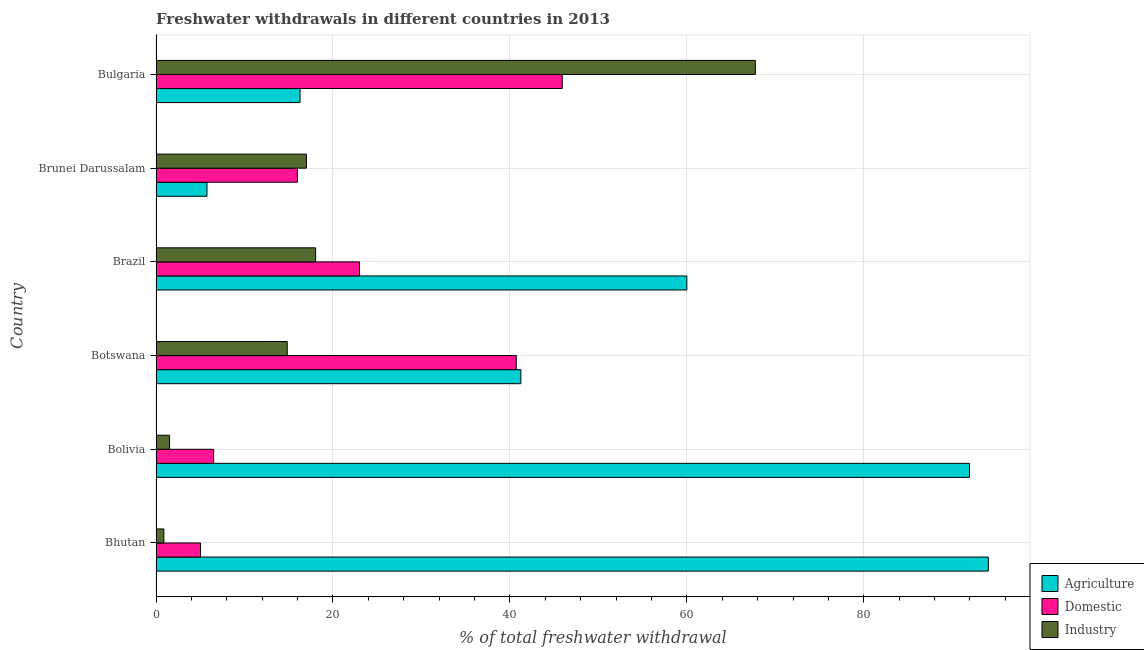How many different coloured bars are there?
Your response must be concise. 3. Are the number of bars per tick equal to the number of legend labels?
Ensure brevity in your answer.  Yes. How many bars are there on the 3rd tick from the top?
Ensure brevity in your answer.  3. What is the label of the 4th group of bars from the top?
Keep it short and to the point. Botswana. What is the percentage of freshwater withdrawal for domestic purposes in Brunei Darussalam?
Your answer should be very brief. 15.98. Across all countries, what is the maximum percentage of freshwater withdrawal for industry?
Offer a terse response. 67.74. Across all countries, what is the minimum percentage of freshwater withdrawal for domestic purposes?
Offer a very short reply. 5.03. In which country was the percentage of freshwater withdrawal for industry maximum?
Provide a succinct answer. Bulgaria. In which country was the percentage of freshwater withdrawal for domestic purposes minimum?
Ensure brevity in your answer.  Bhutan. What is the total percentage of freshwater withdrawal for agriculture in the graph?
Provide a succinct answer. 309.31. What is the difference between the percentage of freshwater withdrawal for agriculture in Brunei Darussalam and that in Bulgaria?
Give a very brief answer. -10.52. What is the difference between the percentage of freshwater withdrawal for agriculture in Bulgaria and the percentage of freshwater withdrawal for domestic purposes in Brunei Darussalam?
Provide a succinct answer. 0.3. What is the average percentage of freshwater withdrawal for agriculture per country?
Your response must be concise. 51.55. What is the difference between the percentage of freshwater withdrawal for industry and percentage of freshwater withdrawal for domestic purposes in Bhutan?
Offer a terse response. -4.14. What is the ratio of the percentage of freshwater withdrawal for industry in Bolivia to that in Brunei Darussalam?
Give a very brief answer. 0.09. Is the difference between the percentage of freshwater withdrawal for agriculture in Bolivia and Botswana greater than the difference between the percentage of freshwater withdrawal for industry in Bolivia and Botswana?
Provide a short and direct response. Yes. What is the difference between the highest and the lowest percentage of freshwater withdrawal for agriculture?
Provide a succinct answer. 88.32. In how many countries, is the percentage of freshwater withdrawal for industry greater than the average percentage of freshwater withdrawal for industry taken over all countries?
Provide a short and direct response. 1. What does the 3rd bar from the top in Bolivia represents?
Make the answer very short. Agriculture. What does the 1st bar from the bottom in Bolivia represents?
Give a very brief answer. Agriculture. Is it the case that in every country, the sum of the percentage of freshwater withdrawal for agriculture and percentage of freshwater withdrawal for domestic purposes is greater than the percentage of freshwater withdrawal for industry?
Make the answer very short. No. How many bars are there?
Ensure brevity in your answer.  18. Are the values on the major ticks of X-axis written in scientific E-notation?
Offer a terse response. No. Where does the legend appear in the graph?
Your response must be concise. Bottom right. How many legend labels are there?
Your answer should be very brief. 3. What is the title of the graph?
Offer a very short reply. Freshwater withdrawals in different countries in 2013. Does "Profit Tax" appear as one of the legend labels in the graph?
Ensure brevity in your answer.  No. What is the label or title of the X-axis?
Ensure brevity in your answer.  % of total freshwater withdrawal. What is the % of total freshwater withdrawal in Agriculture in Bhutan?
Your response must be concise. 94.08. What is the % of total freshwater withdrawal of Domestic in Bhutan?
Your answer should be compact. 5.03. What is the % of total freshwater withdrawal in Industry in Bhutan?
Provide a short and direct response. 0.89. What is the % of total freshwater withdrawal of Agriculture in Bolivia?
Make the answer very short. 91.95. What is the % of total freshwater withdrawal in Domestic in Bolivia?
Your response must be concise. 6.51. What is the % of total freshwater withdrawal of Industry in Bolivia?
Offer a terse response. 1.53. What is the % of total freshwater withdrawal in Agriculture in Botswana?
Offer a terse response. 41.24. What is the % of total freshwater withdrawal of Domestic in Botswana?
Make the answer very short. 40.72. What is the % of total freshwater withdrawal in Industry in Botswana?
Provide a short and direct response. 14.83. What is the % of total freshwater withdrawal of Agriculture in Brazil?
Offer a terse response. 60. What is the % of total freshwater withdrawal of Industry in Brazil?
Ensure brevity in your answer.  18.04. What is the % of total freshwater withdrawal of Agriculture in Brunei Darussalam?
Ensure brevity in your answer.  5.76. What is the % of total freshwater withdrawal in Domestic in Brunei Darussalam?
Your response must be concise. 15.98. What is the % of total freshwater withdrawal in Agriculture in Bulgaria?
Give a very brief answer. 16.28. What is the % of total freshwater withdrawal of Domestic in Bulgaria?
Provide a short and direct response. 45.92. What is the % of total freshwater withdrawal in Industry in Bulgaria?
Offer a very short reply. 67.74. Across all countries, what is the maximum % of total freshwater withdrawal in Agriculture?
Offer a very short reply. 94.08. Across all countries, what is the maximum % of total freshwater withdrawal of Domestic?
Provide a short and direct response. 45.92. Across all countries, what is the maximum % of total freshwater withdrawal in Industry?
Your response must be concise. 67.74. Across all countries, what is the minimum % of total freshwater withdrawal in Agriculture?
Your answer should be very brief. 5.76. Across all countries, what is the minimum % of total freshwater withdrawal of Domestic?
Make the answer very short. 5.03. Across all countries, what is the minimum % of total freshwater withdrawal in Industry?
Offer a very short reply. 0.89. What is the total % of total freshwater withdrawal of Agriculture in the graph?
Your answer should be very brief. 309.31. What is the total % of total freshwater withdrawal of Domestic in the graph?
Your answer should be very brief. 137.16. What is the total % of total freshwater withdrawal of Industry in the graph?
Provide a short and direct response. 120.03. What is the difference between the % of total freshwater withdrawal in Agriculture in Bhutan and that in Bolivia?
Provide a short and direct response. 2.13. What is the difference between the % of total freshwater withdrawal in Domestic in Bhutan and that in Bolivia?
Ensure brevity in your answer.  -1.48. What is the difference between the % of total freshwater withdrawal of Industry in Bhutan and that in Bolivia?
Ensure brevity in your answer.  -0.65. What is the difference between the % of total freshwater withdrawal of Agriculture in Bhutan and that in Botswana?
Offer a very short reply. 52.84. What is the difference between the % of total freshwater withdrawal of Domestic in Bhutan and that in Botswana?
Your answer should be compact. -35.69. What is the difference between the % of total freshwater withdrawal in Industry in Bhutan and that in Botswana?
Ensure brevity in your answer.  -13.94. What is the difference between the % of total freshwater withdrawal in Agriculture in Bhutan and that in Brazil?
Make the answer very short. 34.08. What is the difference between the % of total freshwater withdrawal in Domestic in Bhutan and that in Brazil?
Your response must be concise. -17.97. What is the difference between the % of total freshwater withdrawal of Industry in Bhutan and that in Brazil?
Keep it short and to the point. -17.15. What is the difference between the % of total freshwater withdrawal in Agriculture in Bhutan and that in Brunei Darussalam?
Your answer should be compact. 88.32. What is the difference between the % of total freshwater withdrawal of Domestic in Bhutan and that in Brunei Darussalam?
Give a very brief answer. -10.95. What is the difference between the % of total freshwater withdrawal of Industry in Bhutan and that in Brunei Darussalam?
Offer a very short reply. -16.11. What is the difference between the % of total freshwater withdrawal of Agriculture in Bhutan and that in Bulgaria?
Offer a terse response. 77.8. What is the difference between the % of total freshwater withdrawal in Domestic in Bhutan and that in Bulgaria?
Your response must be concise. -40.89. What is the difference between the % of total freshwater withdrawal of Industry in Bhutan and that in Bulgaria?
Ensure brevity in your answer.  -66.85. What is the difference between the % of total freshwater withdrawal in Agriculture in Bolivia and that in Botswana?
Provide a succinct answer. 50.71. What is the difference between the % of total freshwater withdrawal of Domestic in Bolivia and that in Botswana?
Your answer should be compact. -34.21. What is the difference between the % of total freshwater withdrawal in Industry in Bolivia and that in Botswana?
Offer a very short reply. -13.3. What is the difference between the % of total freshwater withdrawal in Agriculture in Bolivia and that in Brazil?
Make the answer very short. 31.95. What is the difference between the % of total freshwater withdrawal in Domestic in Bolivia and that in Brazil?
Your response must be concise. -16.49. What is the difference between the % of total freshwater withdrawal of Industry in Bolivia and that in Brazil?
Offer a terse response. -16.51. What is the difference between the % of total freshwater withdrawal in Agriculture in Bolivia and that in Brunei Darussalam?
Give a very brief answer. 86.19. What is the difference between the % of total freshwater withdrawal of Domestic in Bolivia and that in Brunei Darussalam?
Provide a short and direct response. -9.47. What is the difference between the % of total freshwater withdrawal of Industry in Bolivia and that in Brunei Darussalam?
Keep it short and to the point. -15.47. What is the difference between the % of total freshwater withdrawal of Agriculture in Bolivia and that in Bulgaria?
Ensure brevity in your answer.  75.67. What is the difference between the % of total freshwater withdrawal of Domestic in Bolivia and that in Bulgaria?
Provide a short and direct response. -39.41. What is the difference between the % of total freshwater withdrawal of Industry in Bolivia and that in Bulgaria?
Offer a very short reply. -66.21. What is the difference between the % of total freshwater withdrawal in Agriculture in Botswana and that in Brazil?
Ensure brevity in your answer.  -18.76. What is the difference between the % of total freshwater withdrawal of Domestic in Botswana and that in Brazil?
Your answer should be compact. 17.72. What is the difference between the % of total freshwater withdrawal in Industry in Botswana and that in Brazil?
Offer a terse response. -3.21. What is the difference between the % of total freshwater withdrawal in Agriculture in Botswana and that in Brunei Darussalam?
Give a very brief answer. 35.48. What is the difference between the % of total freshwater withdrawal in Domestic in Botswana and that in Brunei Darussalam?
Your answer should be very brief. 24.74. What is the difference between the % of total freshwater withdrawal in Industry in Botswana and that in Brunei Darussalam?
Provide a succinct answer. -2.17. What is the difference between the % of total freshwater withdrawal of Agriculture in Botswana and that in Bulgaria?
Give a very brief answer. 24.96. What is the difference between the % of total freshwater withdrawal in Domestic in Botswana and that in Bulgaria?
Keep it short and to the point. -5.2. What is the difference between the % of total freshwater withdrawal of Industry in Botswana and that in Bulgaria?
Your answer should be very brief. -52.91. What is the difference between the % of total freshwater withdrawal in Agriculture in Brazil and that in Brunei Darussalam?
Offer a terse response. 54.24. What is the difference between the % of total freshwater withdrawal of Domestic in Brazil and that in Brunei Darussalam?
Make the answer very short. 7.02. What is the difference between the % of total freshwater withdrawal in Agriculture in Brazil and that in Bulgaria?
Your answer should be very brief. 43.72. What is the difference between the % of total freshwater withdrawal in Domestic in Brazil and that in Bulgaria?
Keep it short and to the point. -22.92. What is the difference between the % of total freshwater withdrawal in Industry in Brazil and that in Bulgaria?
Ensure brevity in your answer.  -49.7. What is the difference between the % of total freshwater withdrawal in Agriculture in Brunei Darussalam and that in Bulgaria?
Provide a short and direct response. -10.52. What is the difference between the % of total freshwater withdrawal of Domestic in Brunei Darussalam and that in Bulgaria?
Give a very brief answer. -29.94. What is the difference between the % of total freshwater withdrawal of Industry in Brunei Darussalam and that in Bulgaria?
Keep it short and to the point. -50.74. What is the difference between the % of total freshwater withdrawal in Agriculture in Bhutan and the % of total freshwater withdrawal in Domestic in Bolivia?
Your answer should be compact. 87.57. What is the difference between the % of total freshwater withdrawal of Agriculture in Bhutan and the % of total freshwater withdrawal of Industry in Bolivia?
Provide a succinct answer. 92.55. What is the difference between the % of total freshwater withdrawal in Domestic in Bhutan and the % of total freshwater withdrawal in Industry in Bolivia?
Give a very brief answer. 3.5. What is the difference between the % of total freshwater withdrawal of Agriculture in Bhutan and the % of total freshwater withdrawal of Domestic in Botswana?
Provide a succinct answer. 53.36. What is the difference between the % of total freshwater withdrawal in Agriculture in Bhutan and the % of total freshwater withdrawal in Industry in Botswana?
Give a very brief answer. 79.25. What is the difference between the % of total freshwater withdrawal in Domestic in Bhutan and the % of total freshwater withdrawal in Industry in Botswana?
Provide a succinct answer. -9.8. What is the difference between the % of total freshwater withdrawal of Agriculture in Bhutan and the % of total freshwater withdrawal of Domestic in Brazil?
Provide a succinct answer. 71.08. What is the difference between the % of total freshwater withdrawal in Agriculture in Bhutan and the % of total freshwater withdrawal in Industry in Brazil?
Provide a short and direct response. 76.04. What is the difference between the % of total freshwater withdrawal of Domestic in Bhutan and the % of total freshwater withdrawal of Industry in Brazil?
Make the answer very short. -13.01. What is the difference between the % of total freshwater withdrawal in Agriculture in Bhutan and the % of total freshwater withdrawal in Domestic in Brunei Darussalam?
Offer a terse response. 78.1. What is the difference between the % of total freshwater withdrawal in Agriculture in Bhutan and the % of total freshwater withdrawal in Industry in Brunei Darussalam?
Keep it short and to the point. 77.08. What is the difference between the % of total freshwater withdrawal in Domestic in Bhutan and the % of total freshwater withdrawal in Industry in Brunei Darussalam?
Provide a succinct answer. -11.97. What is the difference between the % of total freshwater withdrawal of Agriculture in Bhutan and the % of total freshwater withdrawal of Domestic in Bulgaria?
Give a very brief answer. 48.16. What is the difference between the % of total freshwater withdrawal of Agriculture in Bhutan and the % of total freshwater withdrawal of Industry in Bulgaria?
Keep it short and to the point. 26.34. What is the difference between the % of total freshwater withdrawal of Domestic in Bhutan and the % of total freshwater withdrawal of Industry in Bulgaria?
Your response must be concise. -62.71. What is the difference between the % of total freshwater withdrawal in Agriculture in Bolivia and the % of total freshwater withdrawal in Domestic in Botswana?
Your answer should be very brief. 51.23. What is the difference between the % of total freshwater withdrawal of Agriculture in Bolivia and the % of total freshwater withdrawal of Industry in Botswana?
Offer a very short reply. 77.12. What is the difference between the % of total freshwater withdrawal of Domestic in Bolivia and the % of total freshwater withdrawal of Industry in Botswana?
Make the answer very short. -8.32. What is the difference between the % of total freshwater withdrawal of Agriculture in Bolivia and the % of total freshwater withdrawal of Domestic in Brazil?
Your response must be concise. 68.95. What is the difference between the % of total freshwater withdrawal in Agriculture in Bolivia and the % of total freshwater withdrawal in Industry in Brazil?
Provide a short and direct response. 73.91. What is the difference between the % of total freshwater withdrawal of Domestic in Bolivia and the % of total freshwater withdrawal of Industry in Brazil?
Your response must be concise. -11.53. What is the difference between the % of total freshwater withdrawal in Agriculture in Bolivia and the % of total freshwater withdrawal in Domestic in Brunei Darussalam?
Keep it short and to the point. 75.97. What is the difference between the % of total freshwater withdrawal of Agriculture in Bolivia and the % of total freshwater withdrawal of Industry in Brunei Darussalam?
Make the answer very short. 74.95. What is the difference between the % of total freshwater withdrawal of Domestic in Bolivia and the % of total freshwater withdrawal of Industry in Brunei Darussalam?
Offer a terse response. -10.49. What is the difference between the % of total freshwater withdrawal in Agriculture in Bolivia and the % of total freshwater withdrawal in Domestic in Bulgaria?
Ensure brevity in your answer.  46.03. What is the difference between the % of total freshwater withdrawal of Agriculture in Bolivia and the % of total freshwater withdrawal of Industry in Bulgaria?
Keep it short and to the point. 24.21. What is the difference between the % of total freshwater withdrawal of Domestic in Bolivia and the % of total freshwater withdrawal of Industry in Bulgaria?
Keep it short and to the point. -61.23. What is the difference between the % of total freshwater withdrawal of Agriculture in Botswana and the % of total freshwater withdrawal of Domestic in Brazil?
Your answer should be very brief. 18.24. What is the difference between the % of total freshwater withdrawal of Agriculture in Botswana and the % of total freshwater withdrawal of Industry in Brazil?
Your response must be concise. 23.2. What is the difference between the % of total freshwater withdrawal in Domestic in Botswana and the % of total freshwater withdrawal in Industry in Brazil?
Keep it short and to the point. 22.68. What is the difference between the % of total freshwater withdrawal of Agriculture in Botswana and the % of total freshwater withdrawal of Domestic in Brunei Darussalam?
Ensure brevity in your answer.  25.26. What is the difference between the % of total freshwater withdrawal in Agriculture in Botswana and the % of total freshwater withdrawal in Industry in Brunei Darussalam?
Provide a short and direct response. 24.24. What is the difference between the % of total freshwater withdrawal of Domestic in Botswana and the % of total freshwater withdrawal of Industry in Brunei Darussalam?
Your answer should be compact. 23.72. What is the difference between the % of total freshwater withdrawal of Agriculture in Botswana and the % of total freshwater withdrawal of Domestic in Bulgaria?
Keep it short and to the point. -4.68. What is the difference between the % of total freshwater withdrawal in Agriculture in Botswana and the % of total freshwater withdrawal in Industry in Bulgaria?
Ensure brevity in your answer.  -26.5. What is the difference between the % of total freshwater withdrawal of Domestic in Botswana and the % of total freshwater withdrawal of Industry in Bulgaria?
Provide a short and direct response. -27.02. What is the difference between the % of total freshwater withdrawal of Agriculture in Brazil and the % of total freshwater withdrawal of Domestic in Brunei Darussalam?
Make the answer very short. 44.02. What is the difference between the % of total freshwater withdrawal in Agriculture in Brazil and the % of total freshwater withdrawal in Industry in Brunei Darussalam?
Offer a terse response. 43. What is the difference between the % of total freshwater withdrawal of Domestic in Brazil and the % of total freshwater withdrawal of Industry in Brunei Darussalam?
Ensure brevity in your answer.  6. What is the difference between the % of total freshwater withdrawal of Agriculture in Brazil and the % of total freshwater withdrawal of Domestic in Bulgaria?
Offer a very short reply. 14.08. What is the difference between the % of total freshwater withdrawal in Agriculture in Brazil and the % of total freshwater withdrawal in Industry in Bulgaria?
Provide a short and direct response. -7.74. What is the difference between the % of total freshwater withdrawal of Domestic in Brazil and the % of total freshwater withdrawal of Industry in Bulgaria?
Keep it short and to the point. -44.74. What is the difference between the % of total freshwater withdrawal of Agriculture in Brunei Darussalam and the % of total freshwater withdrawal of Domestic in Bulgaria?
Make the answer very short. -40.16. What is the difference between the % of total freshwater withdrawal of Agriculture in Brunei Darussalam and the % of total freshwater withdrawal of Industry in Bulgaria?
Your response must be concise. -61.98. What is the difference between the % of total freshwater withdrawal in Domestic in Brunei Darussalam and the % of total freshwater withdrawal in Industry in Bulgaria?
Ensure brevity in your answer.  -51.76. What is the average % of total freshwater withdrawal in Agriculture per country?
Provide a succinct answer. 51.55. What is the average % of total freshwater withdrawal of Domestic per country?
Your answer should be compact. 22.86. What is the average % of total freshwater withdrawal of Industry per country?
Provide a short and direct response. 20.01. What is the difference between the % of total freshwater withdrawal of Agriculture and % of total freshwater withdrawal of Domestic in Bhutan?
Your answer should be compact. 89.05. What is the difference between the % of total freshwater withdrawal in Agriculture and % of total freshwater withdrawal in Industry in Bhutan?
Your answer should be very brief. 93.19. What is the difference between the % of total freshwater withdrawal of Domestic and % of total freshwater withdrawal of Industry in Bhutan?
Give a very brief answer. 4.14. What is the difference between the % of total freshwater withdrawal in Agriculture and % of total freshwater withdrawal in Domestic in Bolivia?
Provide a succinct answer. 85.44. What is the difference between the % of total freshwater withdrawal in Agriculture and % of total freshwater withdrawal in Industry in Bolivia?
Make the answer very short. 90.42. What is the difference between the % of total freshwater withdrawal of Domestic and % of total freshwater withdrawal of Industry in Bolivia?
Your response must be concise. 4.98. What is the difference between the % of total freshwater withdrawal in Agriculture and % of total freshwater withdrawal in Domestic in Botswana?
Give a very brief answer. 0.52. What is the difference between the % of total freshwater withdrawal in Agriculture and % of total freshwater withdrawal in Industry in Botswana?
Make the answer very short. 26.41. What is the difference between the % of total freshwater withdrawal of Domestic and % of total freshwater withdrawal of Industry in Botswana?
Keep it short and to the point. 25.89. What is the difference between the % of total freshwater withdrawal in Agriculture and % of total freshwater withdrawal in Domestic in Brazil?
Provide a succinct answer. 37. What is the difference between the % of total freshwater withdrawal in Agriculture and % of total freshwater withdrawal in Industry in Brazil?
Ensure brevity in your answer.  41.96. What is the difference between the % of total freshwater withdrawal in Domestic and % of total freshwater withdrawal in Industry in Brazil?
Make the answer very short. 4.96. What is the difference between the % of total freshwater withdrawal of Agriculture and % of total freshwater withdrawal of Domestic in Brunei Darussalam?
Offer a terse response. -10.22. What is the difference between the % of total freshwater withdrawal of Agriculture and % of total freshwater withdrawal of Industry in Brunei Darussalam?
Provide a succinct answer. -11.24. What is the difference between the % of total freshwater withdrawal of Domestic and % of total freshwater withdrawal of Industry in Brunei Darussalam?
Ensure brevity in your answer.  -1.02. What is the difference between the % of total freshwater withdrawal in Agriculture and % of total freshwater withdrawal in Domestic in Bulgaria?
Provide a short and direct response. -29.64. What is the difference between the % of total freshwater withdrawal in Agriculture and % of total freshwater withdrawal in Industry in Bulgaria?
Keep it short and to the point. -51.46. What is the difference between the % of total freshwater withdrawal of Domestic and % of total freshwater withdrawal of Industry in Bulgaria?
Make the answer very short. -21.82. What is the ratio of the % of total freshwater withdrawal in Agriculture in Bhutan to that in Bolivia?
Make the answer very short. 1.02. What is the ratio of the % of total freshwater withdrawal in Domestic in Bhutan to that in Bolivia?
Make the answer very short. 0.77. What is the ratio of the % of total freshwater withdrawal in Industry in Bhutan to that in Bolivia?
Offer a terse response. 0.58. What is the ratio of the % of total freshwater withdrawal in Agriculture in Bhutan to that in Botswana?
Make the answer very short. 2.28. What is the ratio of the % of total freshwater withdrawal in Domestic in Bhutan to that in Botswana?
Offer a very short reply. 0.12. What is the ratio of the % of total freshwater withdrawal in Industry in Bhutan to that in Botswana?
Your answer should be very brief. 0.06. What is the ratio of the % of total freshwater withdrawal in Agriculture in Bhutan to that in Brazil?
Make the answer very short. 1.57. What is the ratio of the % of total freshwater withdrawal of Domestic in Bhutan to that in Brazil?
Your answer should be very brief. 0.22. What is the ratio of the % of total freshwater withdrawal of Industry in Bhutan to that in Brazil?
Your answer should be very brief. 0.05. What is the ratio of the % of total freshwater withdrawal in Agriculture in Bhutan to that in Brunei Darussalam?
Your response must be concise. 16.33. What is the ratio of the % of total freshwater withdrawal of Domestic in Bhutan to that in Brunei Darussalam?
Make the answer very short. 0.31. What is the ratio of the % of total freshwater withdrawal of Industry in Bhutan to that in Brunei Darussalam?
Give a very brief answer. 0.05. What is the ratio of the % of total freshwater withdrawal in Agriculture in Bhutan to that in Bulgaria?
Your answer should be compact. 5.78. What is the ratio of the % of total freshwater withdrawal in Domestic in Bhutan to that in Bulgaria?
Offer a very short reply. 0.11. What is the ratio of the % of total freshwater withdrawal in Industry in Bhutan to that in Bulgaria?
Your answer should be compact. 0.01. What is the ratio of the % of total freshwater withdrawal of Agriculture in Bolivia to that in Botswana?
Provide a succinct answer. 2.23. What is the ratio of the % of total freshwater withdrawal in Domestic in Bolivia to that in Botswana?
Your answer should be very brief. 0.16. What is the ratio of the % of total freshwater withdrawal of Industry in Bolivia to that in Botswana?
Your response must be concise. 0.1. What is the ratio of the % of total freshwater withdrawal in Agriculture in Bolivia to that in Brazil?
Keep it short and to the point. 1.53. What is the ratio of the % of total freshwater withdrawal of Domestic in Bolivia to that in Brazil?
Ensure brevity in your answer.  0.28. What is the ratio of the % of total freshwater withdrawal in Industry in Bolivia to that in Brazil?
Give a very brief answer. 0.09. What is the ratio of the % of total freshwater withdrawal of Agriculture in Bolivia to that in Brunei Darussalam?
Your response must be concise. 15.96. What is the ratio of the % of total freshwater withdrawal in Domestic in Bolivia to that in Brunei Darussalam?
Offer a very short reply. 0.41. What is the ratio of the % of total freshwater withdrawal of Industry in Bolivia to that in Brunei Darussalam?
Keep it short and to the point. 0.09. What is the ratio of the % of total freshwater withdrawal in Agriculture in Bolivia to that in Bulgaria?
Provide a short and direct response. 5.65. What is the ratio of the % of total freshwater withdrawal in Domestic in Bolivia to that in Bulgaria?
Ensure brevity in your answer.  0.14. What is the ratio of the % of total freshwater withdrawal in Industry in Bolivia to that in Bulgaria?
Make the answer very short. 0.02. What is the ratio of the % of total freshwater withdrawal of Agriculture in Botswana to that in Brazil?
Your answer should be compact. 0.69. What is the ratio of the % of total freshwater withdrawal of Domestic in Botswana to that in Brazil?
Keep it short and to the point. 1.77. What is the ratio of the % of total freshwater withdrawal in Industry in Botswana to that in Brazil?
Offer a very short reply. 0.82. What is the ratio of the % of total freshwater withdrawal of Agriculture in Botswana to that in Brunei Darussalam?
Ensure brevity in your answer.  7.16. What is the ratio of the % of total freshwater withdrawal in Domestic in Botswana to that in Brunei Darussalam?
Offer a very short reply. 2.55. What is the ratio of the % of total freshwater withdrawal in Industry in Botswana to that in Brunei Darussalam?
Provide a succinct answer. 0.87. What is the ratio of the % of total freshwater withdrawal of Agriculture in Botswana to that in Bulgaria?
Give a very brief answer. 2.53. What is the ratio of the % of total freshwater withdrawal of Domestic in Botswana to that in Bulgaria?
Provide a short and direct response. 0.89. What is the ratio of the % of total freshwater withdrawal of Industry in Botswana to that in Bulgaria?
Offer a very short reply. 0.22. What is the ratio of the % of total freshwater withdrawal of Agriculture in Brazil to that in Brunei Darussalam?
Provide a succinct answer. 10.41. What is the ratio of the % of total freshwater withdrawal of Domestic in Brazil to that in Brunei Darussalam?
Ensure brevity in your answer.  1.44. What is the ratio of the % of total freshwater withdrawal of Industry in Brazil to that in Brunei Darussalam?
Offer a terse response. 1.06. What is the ratio of the % of total freshwater withdrawal in Agriculture in Brazil to that in Bulgaria?
Provide a succinct answer. 3.69. What is the ratio of the % of total freshwater withdrawal in Domestic in Brazil to that in Bulgaria?
Provide a short and direct response. 0.5. What is the ratio of the % of total freshwater withdrawal of Industry in Brazil to that in Bulgaria?
Ensure brevity in your answer.  0.27. What is the ratio of the % of total freshwater withdrawal in Agriculture in Brunei Darussalam to that in Bulgaria?
Ensure brevity in your answer.  0.35. What is the ratio of the % of total freshwater withdrawal in Domestic in Brunei Darussalam to that in Bulgaria?
Offer a very short reply. 0.35. What is the ratio of the % of total freshwater withdrawal in Industry in Brunei Darussalam to that in Bulgaria?
Your answer should be very brief. 0.25. What is the difference between the highest and the second highest % of total freshwater withdrawal of Agriculture?
Offer a very short reply. 2.13. What is the difference between the highest and the second highest % of total freshwater withdrawal in Domestic?
Provide a succinct answer. 5.2. What is the difference between the highest and the second highest % of total freshwater withdrawal of Industry?
Your answer should be very brief. 49.7. What is the difference between the highest and the lowest % of total freshwater withdrawal of Agriculture?
Your answer should be compact. 88.32. What is the difference between the highest and the lowest % of total freshwater withdrawal in Domestic?
Offer a terse response. 40.89. What is the difference between the highest and the lowest % of total freshwater withdrawal in Industry?
Offer a very short reply. 66.85. 